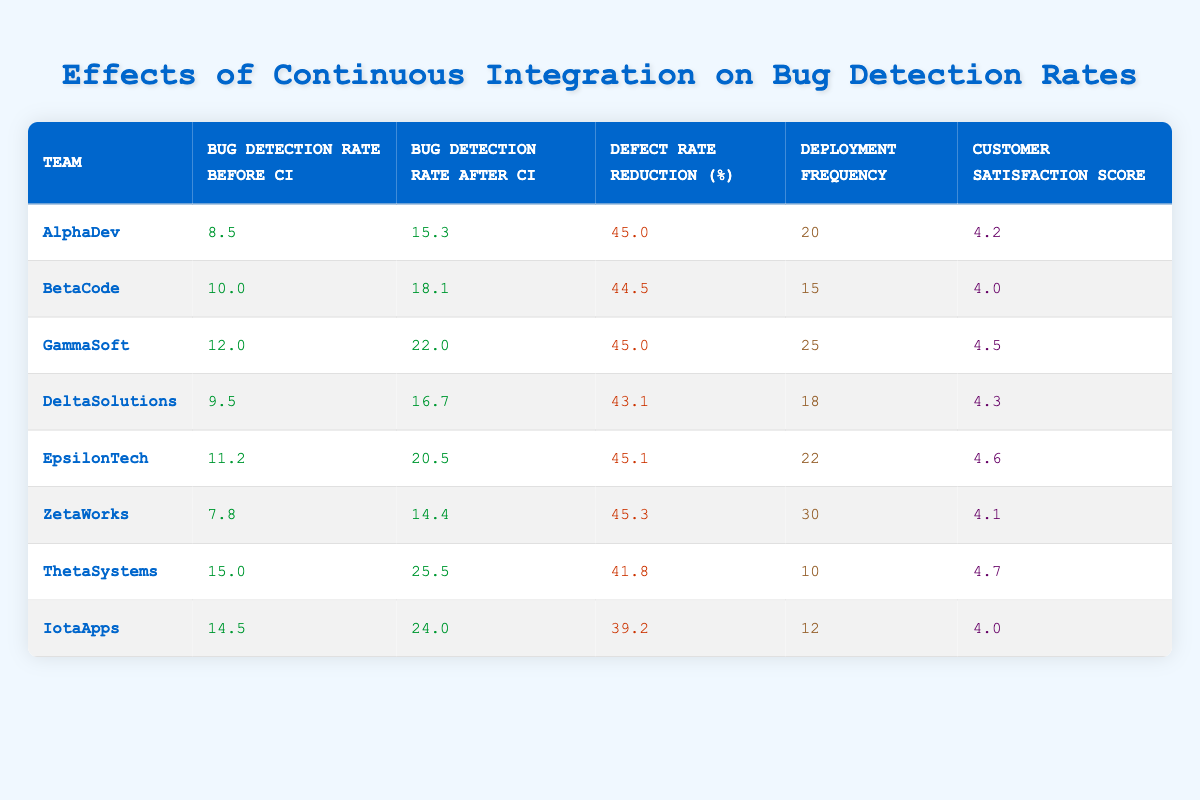What was the Bug Detection Rate for AlphaDev before Continuous Integration? The Bug Detection Rate for AlphaDev before Continuous Integration is found in the second column of the table. It is listed as 8.5.
Answer: 8.5 What is the Defect Rate Reduction for EpsilonTech? The Defect Rate Reduction for EpsilonTech can be found in the fourth column of the table. It is listed as 45.1.
Answer: 45.1 Which team had the highest Bug Detection Rate After Continuous Integration? The Bug Detection Rate After Continuous Integration is in the third column. By examining the values in that column, GammaSoft has the highest rate at 22.0.
Answer: GammaSoft What is the average Customer Satisfaction Score for all teams? The Customer Satisfaction scores are 4.2, 4.0, 4.5, 4.3, 4.6, 4.1, 4.7, and 4.0. Adding these together equals 33.4. Dividing by the number of teams (8), gives an average of 33.4 / 8 = 4.175.
Answer: 4.175 Is the Deployment Frequency for ThetaSystems greater than the average Deployment Frequency across all teams? The Deployment Frequencies for all teams are 20, 15, 25, 18, 22, 30, 10, and 12, summing to 152. The average Deployment Frequency is 152 / 8 = 19. The Deployment Frequency for ThetaSystems is 10, which is less than 19.
Answer: No Which team had a lower Bug Detection Rate After CI compared to their Bug Detection Rate Before CI? A comparison is needed between the second and third columns for all teams. Upon examination, none of the teams reported a lower Bug Detection Rate After CI. All values increased.
Answer: None What is the difference in Bug Detection Rates before and after Continuous Integration for IotaApps? The Bug Detection Rate for IotaApps before CI is 14.5 and after is 24.0. The difference is calculated as 24.0 - 14.5 = 9.5.
Answer: 9.5 How many teams had a Customer Satisfaction Score higher than 4.5? The scores are 4.2, 4.0, 4.5, 4.3, 4.6, 4.1, 4.7, and 4.0. Only EpsilonTech (4.6) and ThetaSystems (4.7) have scores higher than 4.5, totaling 2 teams.
Answer: 2 What percentage of Defect Rate Reduction was achieved by GammaSoft? The Defect Rate Reduction for GammaSoft is in the fourth column and listed as 45.0. This indicates that GammaSoft achieved a 45.0% defect rate reduction.
Answer: 45.0% 